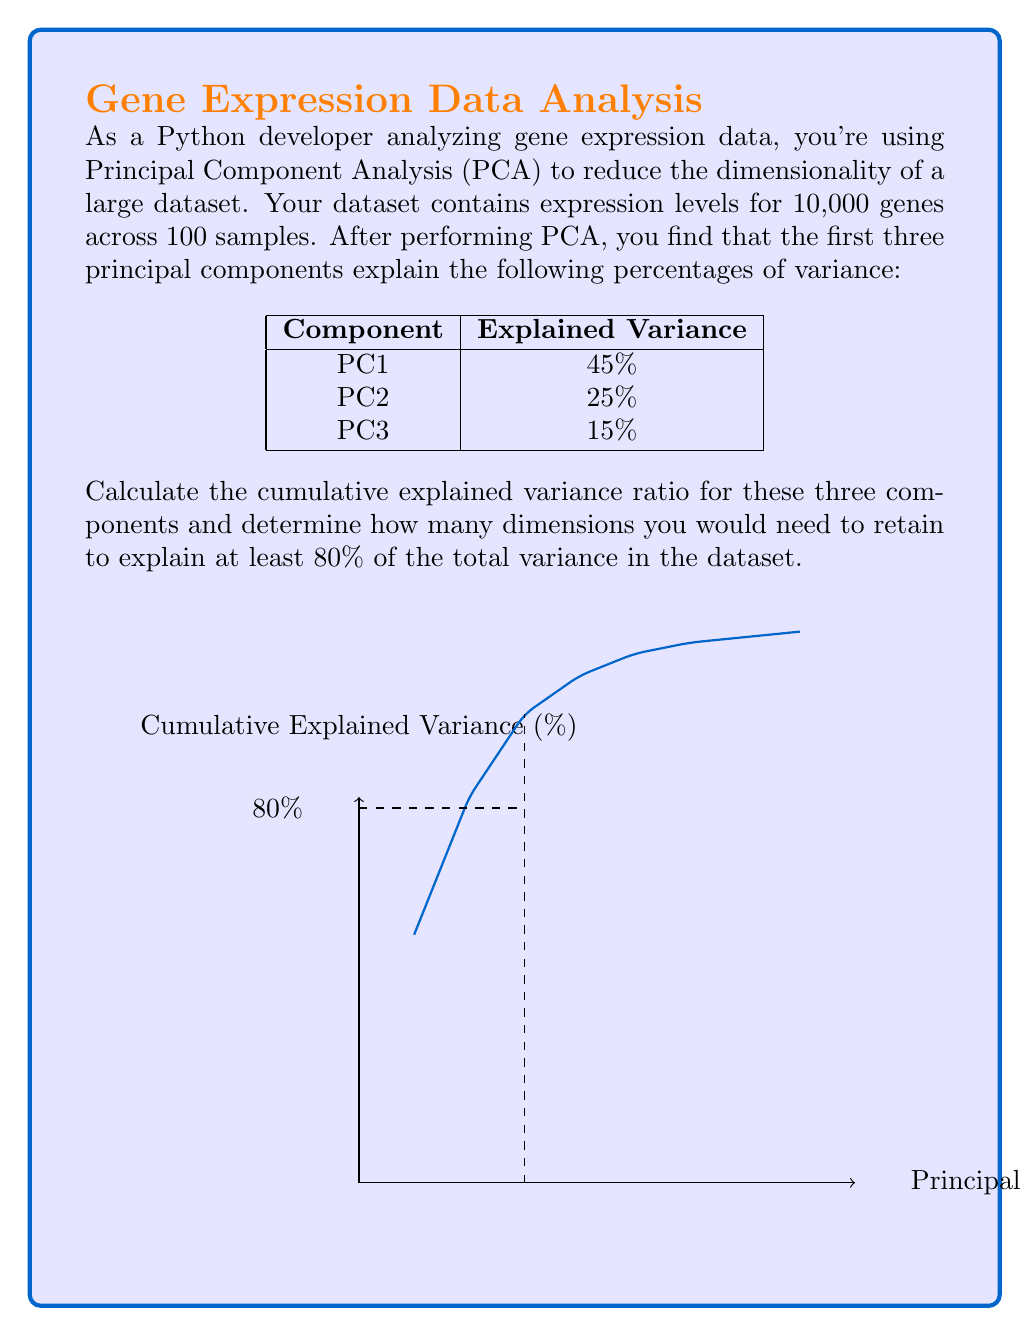What is the answer to this math problem? Let's approach this step-by-step:

1. Calculate the cumulative explained variance ratio:
   The cumulative explained variance ratio is the sum of the individual explained variance ratios.
   
   $$\text{Cumulative Explained Variance} = PC1 + PC2 + PC3$$
   $$= 45\% + 25\% + 15\% = 85\%$$

2. Convert to decimal form:
   $$85\% = 0.85$$

3. Compare to the required threshold:
   The question asks for at least 80% of the total variance, which is 0.80.
   Since 0.85 > 0.80, the first three principal components are sufficient.

4. Determine the number of dimensions to retain:
   As we only need the first three principal components to exceed 80% explained variance, we would retain 3 dimensions.

In Python, you might perform this analysis using libraries like numpy and sklearn:

```python
import numpy as np
from sklearn.decomposition import PCA

# Assuming X is your gene expression data
pca = PCA()
pca.fit(X)

cumulative_variance_ratio = np.cumsum(pca.explained_variance_ratio_)
n_components = np.argmax(cumulative_variance_ratio >= 0.8) + 1
```

This code would give you the number of components needed to explain at least 80% of the variance, which in this case would be 3.
Answer: 3 dimensions 